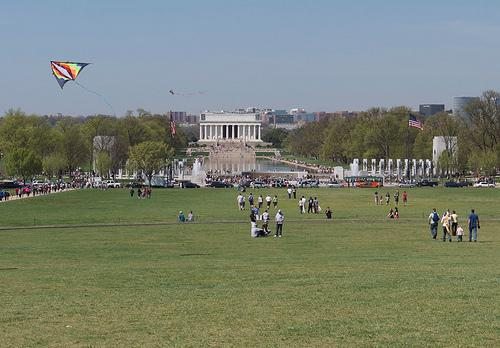Question: how many kites flying?
Choices:
A. Three.
B. Two.
C. Four.
D. Five.
Answer with the letter. Answer: B Question: where are the people?
Choices:
A. At the park.
B. At the beach.
C. At a concert.
D. At a baseball game.
Answer with the letter. Answer: A Question: what is the color of the grass?
Choices:
A. Green.
B. Brown.
C. Yellow.
D. Blue.
Answer with the letter. Answer: A Question: why the people at the park?
Choices:
A. Birthday party.
B. To play.
C. To hang out.
D. To fly kites.
Answer with the letter. Answer: C Question: what is the color of the sky?
Choices:
A. Black.
B. Blue and gray.
C. Red.
D. Purple.
Answer with the letter. Answer: B Question: when did the people arrived?
Choices:
A. This afternoon.
B. This evening.
C. Around noon.
D. This morning.
Answer with the letter. Answer: D Question: who are at the park?
Choices:
A. Children.
B. Men.
C. People.
D. Women.
Answer with the letter. Answer: C 